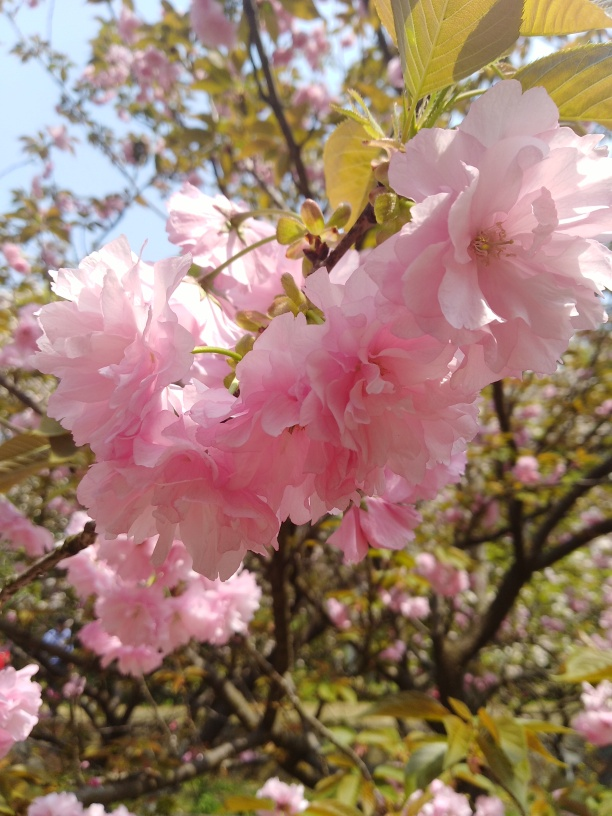Can you tell me if this species of cherry blossom is native to Japan? Yes, the species of cherry blossom seen here, with its densely packed clusters of double-flowered blossoms, is indeed native to Japan. These trees are often associated with the traditional Japanese custom of hanami, which involves viewing and appreciating the transient beauty of flowers. 